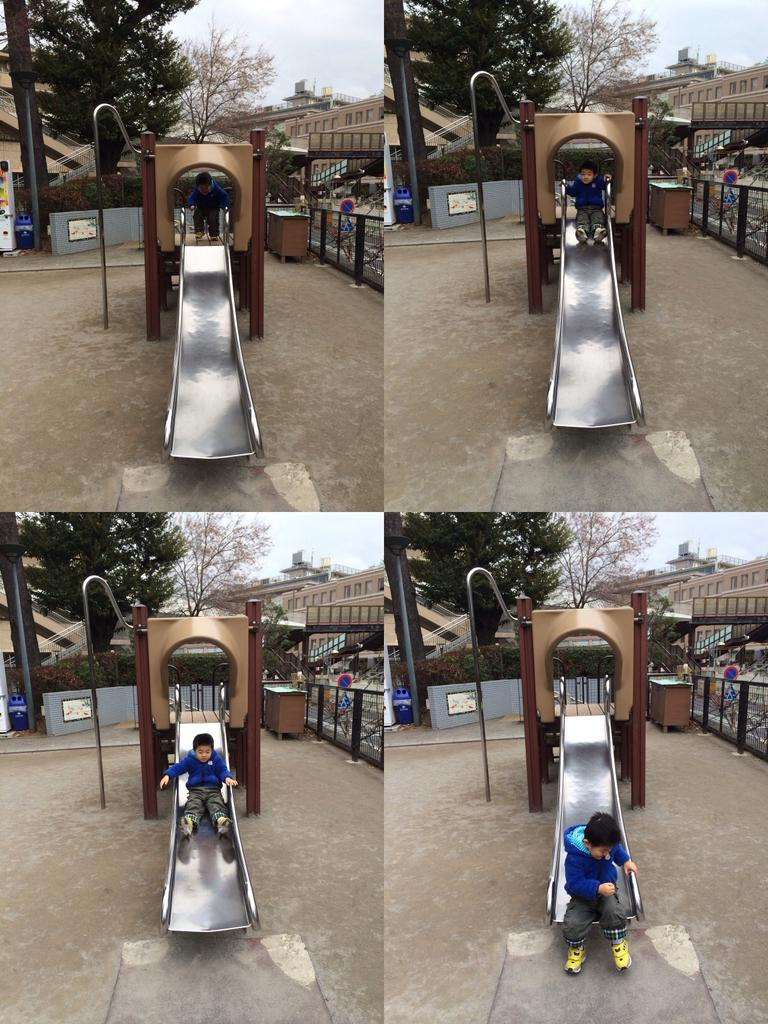Who is present in the image? There is a boy in the image. What is the boy doing in the image? The boy is on a slide. What can be seen in the background of the image? There are trees and buildings visible in the image. What type of punishment is the boy receiving in the image? There is no indication in the image that the boy is receiving any punishment. Can you see a stream in the image? There is no stream visible in the image. 